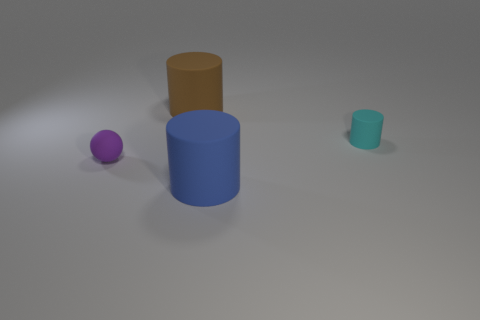Is there anything else that is the same size as the blue cylinder?
Give a very brief answer. Yes. What shape is the tiny matte object on the right side of the cylinder behind the small cyan matte object?
Offer a terse response. Cylinder. Are the small object to the left of the small cyan matte thing and the small thing that is behind the small purple matte object made of the same material?
Offer a terse response. Yes. How many large rubber cylinders are behind the small rubber object that is to the left of the big brown object?
Ensure brevity in your answer.  1. Does the small matte object that is behind the ball have the same shape as the big object that is behind the blue rubber object?
Ensure brevity in your answer.  Yes. What size is the object that is both behind the small ball and left of the tiny cyan rubber cylinder?
Make the answer very short. Large. What color is the other small rubber object that is the same shape as the brown rubber thing?
Your answer should be very brief. Cyan. There is a tiny object left of the large blue cylinder that is in front of the tiny purple sphere; what color is it?
Provide a short and direct response. Purple. There is a tiny purple rubber object; what shape is it?
Offer a terse response. Sphere. There is a matte thing that is to the left of the big blue cylinder and in front of the brown object; what is its shape?
Offer a very short reply. Sphere. 